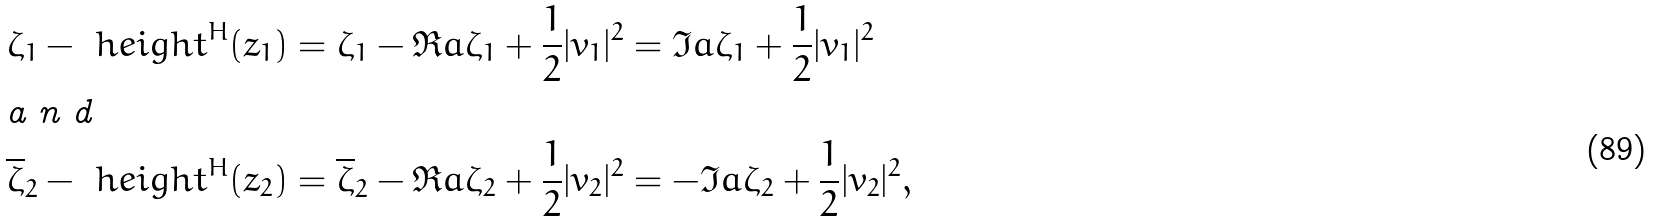Convert formula to latex. <formula><loc_0><loc_0><loc_500><loc_500>\zeta _ { 1 } - \ h e i g h t ^ { H } ( z _ { 1 } ) & = \zeta _ { 1 } - \Re a \zeta _ { 1 } + \frac { 1 } { 2 } | v _ { 1 } | ^ { 2 } = \Im a \zeta _ { 1 } + \frac { 1 } { 2 } | v _ { 1 } | ^ { 2 } \intertext { a n d } \overline { \zeta } _ { 2 } - \ h e i g h t ^ { H } ( z _ { 2 } ) & = \overline { \zeta } _ { 2 } - \Re a \zeta _ { 2 } + \frac { 1 } { 2 } | v _ { 2 } | ^ { 2 } = - \Im a \zeta _ { 2 } + \frac { 1 } { 2 } | v _ { 2 } | ^ { 2 } ,</formula> 